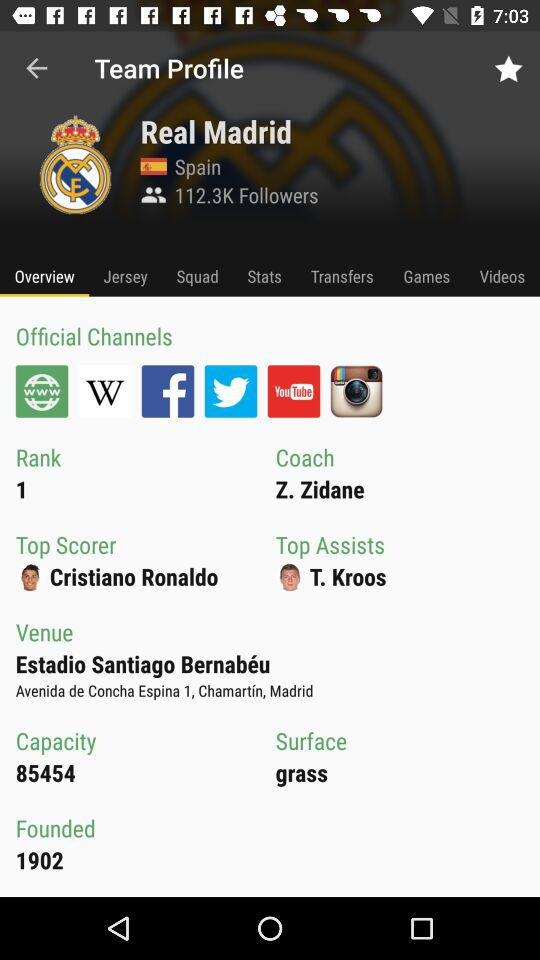Where is the venue? The venue is Estadio Santiago Bernabéu Avenida de Concha Espina 1, Chamartín, Madrid. 